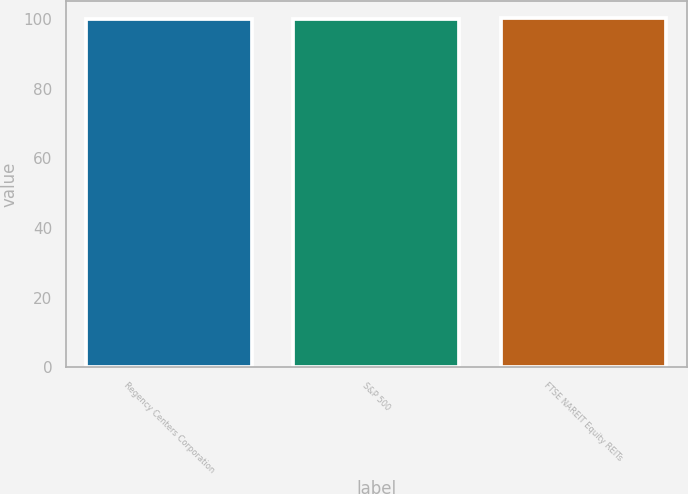<chart> <loc_0><loc_0><loc_500><loc_500><bar_chart><fcel>Regency Centers Corporation<fcel>S&P 500<fcel>FTSE NAREIT Equity REITs<nl><fcel>100<fcel>100.1<fcel>100.2<nl></chart> 